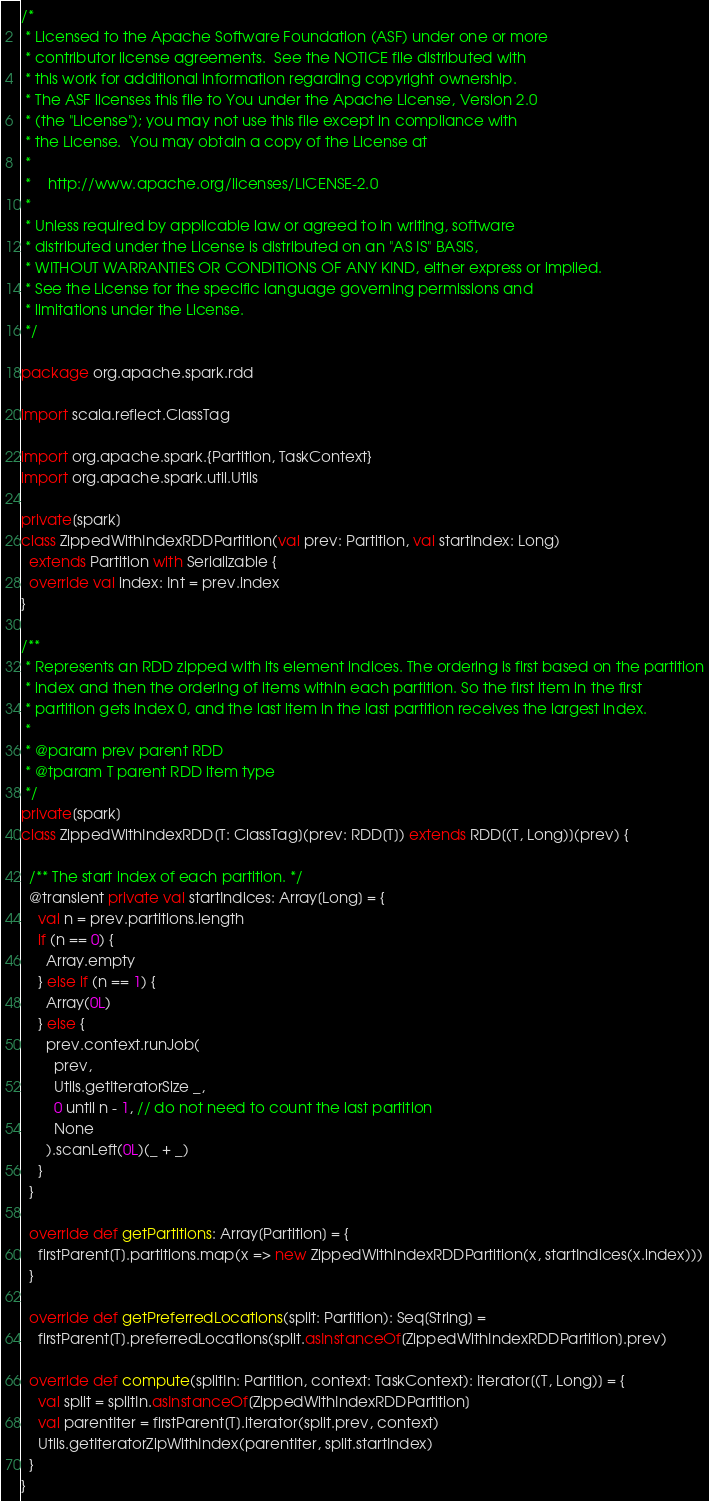Convert code to text. <code><loc_0><loc_0><loc_500><loc_500><_Scala_>/*
 * Licensed to the Apache Software Foundation (ASF) under one or more
 * contributor license agreements.  See the NOTICE file distributed with
 * this work for additional information regarding copyright ownership.
 * The ASF licenses this file to You under the Apache License, Version 2.0
 * (the "License"); you may not use this file except in compliance with
 * the License.  You may obtain a copy of the License at
 *
 *    http://www.apache.org/licenses/LICENSE-2.0
 *
 * Unless required by applicable law or agreed to in writing, software
 * distributed under the License is distributed on an "AS IS" BASIS,
 * WITHOUT WARRANTIES OR CONDITIONS OF ANY KIND, either express or implied.
 * See the License for the specific language governing permissions and
 * limitations under the License.
 */

package org.apache.spark.rdd

import scala.reflect.ClassTag

import org.apache.spark.{Partition, TaskContext}
import org.apache.spark.util.Utils

private[spark]
class ZippedWithIndexRDDPartition(val prev: Partition, val startIndex: Long)
  extends Partition with Serializable {
  override val index: Int = prev.index
}

/**
 * Represents an RDD zipped with its element indices. The ordering is first based on the partition
 * index and then the ordering of items within each partition. So the first item in the first
 * partition gets index 0, and the last item in the last partition receives the largest index.
 *
 * @param prev parent RDD
 * @tparam T parent RDD item type
 */
private[spark]
class ZippedWithIndexRDD[T: ClassTag](prev: RDD[T]) extends RDD[(T, Long)](prev) {

  /** The start index of each partition. */
  @transient private val startIndices: Array[Long] = {
    val n = prev.partitions.length
    if (n == 0) {
      Array.empty
    } else if (n == 1) {
      Array(0L)
    } else {
      prev.context.runJob(
        prev,
        Utils.getIteratorSize _,
        0 until n - 1, // do not need to count the last partition
        None
      ).scanLeft(0L)(_ + _)
    }
  }

  override def getPartitions: Array[Partition] = {
    firstParent[T].partitions.map(x => new ZippedWithIndexRDDPartition(x, startIndices(x.index)))
  }

  override def getPreferredLocations(split: Partition): Seq[String] =
    firstParent[T].preferredLocations(split.asInstanceOf[ZippedWithIndexRDDPartition].prev)

  override def compute(splitIn: Partition, context: TaskContext): Iterator[(T, Long)] = {
    val split = splitIn.asInstanceOf[ZippedWithIndexRDDPartition]
    val parentIter = firstParent[T].iterator(split.prev, context)
    Utils.getIteratorZipWithIndex(parentIter, split.startIndex)
  }
}
</code> 